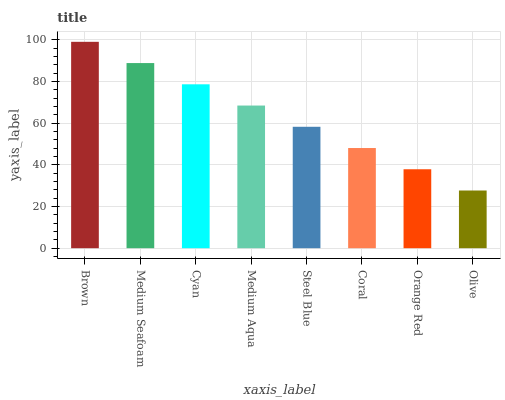Is Olive the minimum?
Answer yes or no. Yes. Is Brown the maximum?
Answer yes or no. Yes. Is Medium Seafoam the minimum?
Answer yes or no. No. Is Medium Seafoam the maximum?
Answer yes or no. No. Is Brown greater than Medium Seafoam?
Answer yes or no. Yes. Is Medium Seafoam less than Brown?
Answer yes or no. Yes. Is Medium Seafoam greater than Brown?
Answer yes or no. No. Is Brown less than Medium Seafoam?
Answer yes or no. No. Is Medium Aqua the high median?
Answer yes or no. Yes. Is Steel Blue the low median?
Answer yes or no. Yes. Is Coral the high median?
Answer yes or no. No. Is Cyan the low median?
Answer yes or no. No. 